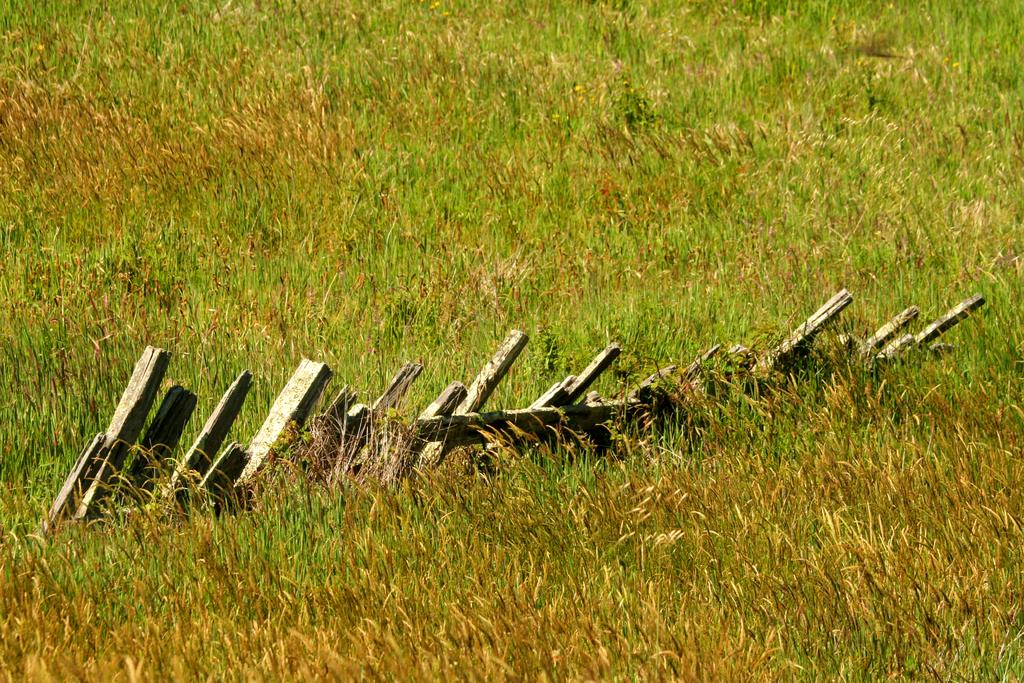What type of vegetation is present at the bottom of the image? There is grass at the bottom of the image. What can be seen in the middle of the image? There are wooden sticks or a wooden fence in the middle of the image. What is visible in the background of the image? There is grass visible in the background of the image. Where is the sink located in the image? There is no sink present in the image. What type of balls can be seen rolling on the grass in the background? There are no balls present in the image; it only features grass in the background. 